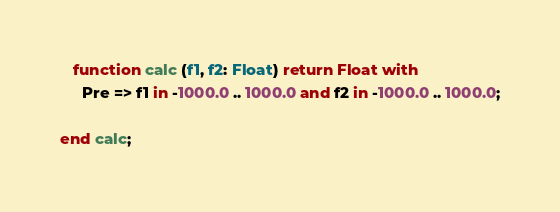Convert code to text. <code><loc_0><loc_0><loc_500><loc_500><_Ada_>   function calc (f1, f2: Float) return Float with
     Pre => f1 in -1000.0 .. 1000.0 and f2 in -1000.0 .. 1000.0;

end calc;
</code> 